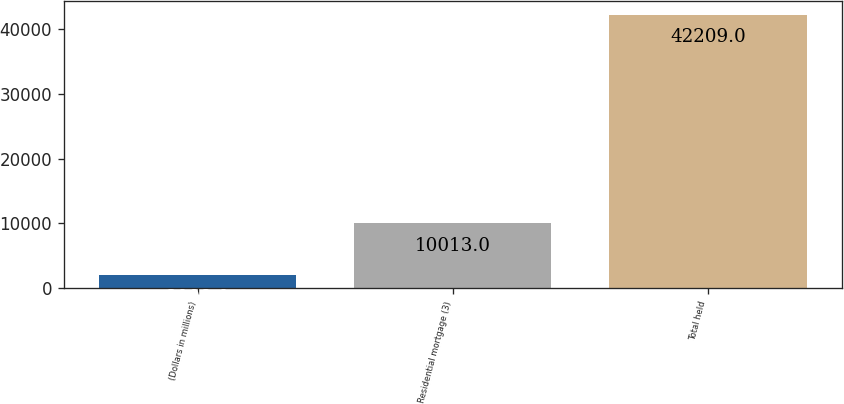Convert chart to OTSL. <chart><loc_0><loc_0><loc_500><loc_500><bar_chart><fcel>(Dollars in millions)<fcel>Residential mortgage (3)<fcel>Total held<nl><fcel>2008<fcel>10013<fcel>42209<nl></chart> 